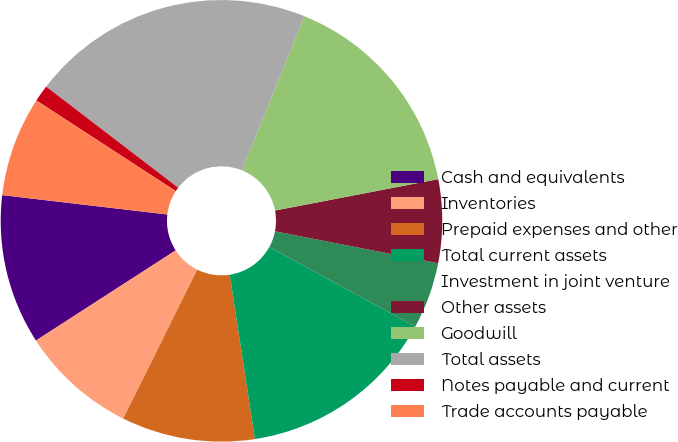<chart> <loc_0><loc_0><loc_500><loc_500><pie_chart><fcel>Cash and equivalents<fcel>Inventories<fcel>Prepaid expenses and other<fcel>Total current assets<fcel>Investment in joint venture<fcel>Other assets<fcel>Goodwill<fcel>Total assets<fcel>Notes payable and current<fcel>Trade accounts payable<nl><fcel>10.98%<fcel>8.54%<fcel>9.76%<fcel>14.63%<fcel>4.88%<fcel>6.1%<fcel>15.85%<fcel>20.73%<fcel>1.22%<fcel>7.32%<nl></chart> 